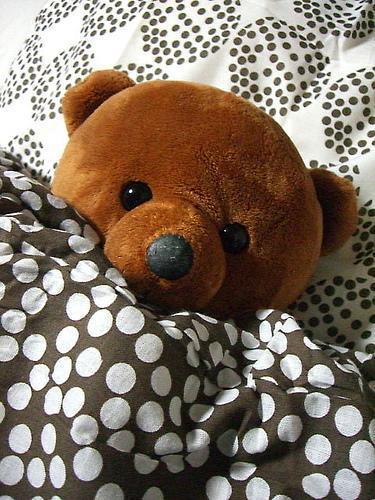How many sheep are grazing?
Give a very brief answer. 0. 